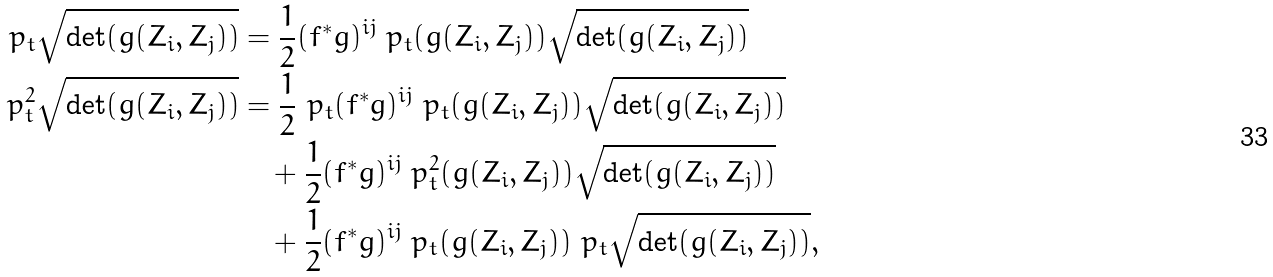Convert formula to latex. <formula><loc_0><loc_0><loc_500><loc_500>\ p _ { t } \sqrt { \det ( g ( Z _ { i } , Z _ { j } ) ) } & = \frac { 1 } { 2 } ( f ^ { * } g ) ^ { i j } \ p _ { t } ( g ( Z _ { i } , Z _ { j } ) ) \sqrt { \det ( g ( Z _ { i } , Z _ { j } ) ) } \\ \ p _ { t } ^ { 2 } \sqrt { \det ( g ( Z _ { i } , Z _ { j } ) ) } & = \frac { 1 } { 2 } \ p _ { t } ( f ^ { * } g ) ^ { i j } \ p _ { t } ( g ( Z _ { i } , Z _ { j } ) ) \sqrt { \det ( g ( Z _ { i } , Z _ { j } ) ) } \\ & \quad + \frac { 1 } { 2 } ( f ^ { * } g ) ^ { i j } \ p _ { t } ^ { 2 } ( g ( Z _ { i } , Z _ { j } ) ) \sqrt { \det ( g ( Z _ { i } , Z _ { j } ) ) } \\ & \quad + \frac { 1 } { 2 } ( f ^ { * } g ) ^ { i j } \ p _ { t } ( g ( Z _ { i } , Z _ { j } ) ) \ p _ { t } \sqrt { \det ( g ( Z _ { i } , Z _ { j } ) ) } ,</formula> 